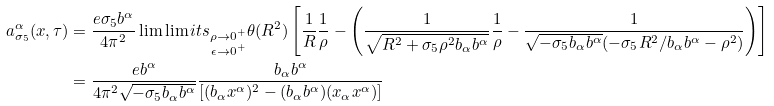Convert formula to latex. <formula><loc_0><loc_0><loc_500><loc_500>a _ { \sigma _ { 5 } } ^ { \alpha } ( x , \tau ) & = \frac { e \sigma _ { 5 } b ^ { \alpha } } { 4 \pi ^ { 2 } } \lim \lim i t s _ { \substack { \rho \to 0 ^ { + } \\ \epsilon \to 0 ^ { + } } } \theta ( R ^ { 2 } ) \left [ \frac { 1 } { R } \frac { 1 } { \rho } - \left ( \frac { 1 } { \sqrt { R ^ { 2 } + \sigma _ { 5 } \rho ^ { 2 } b _ { \alpha } b ^ { \alpha } } } \frac { 1 } { \rho } - \frac { 1 } { \sqrt { - \sigma _ { 5 } b _ { \alpha } b ^ { \alpha } } ( - \sigma _ { 5 } R ^ { 2 } / b _ { \alpha } b ^ { \alpha } - \rho ^ { 2 } ) } \right ) \right ] \\ & = \frac { e b ^ { \alpha } } { 4 \pi ^ { 2 } \sqrt { - \sigma _ { 5 } b _ { \alpha } b ^ { \alpha } } } \frac { b _ { \alpha } b ^ { \alpha } } { \left [ ( b _ { \alpha } x ^ { \alpha } ) ^ { 2 } - ( b _ { \alpha } b ^ { \alpha } ) ( x _ { \alpha } x ^ { \alpha } ) \right ] }</formula> 